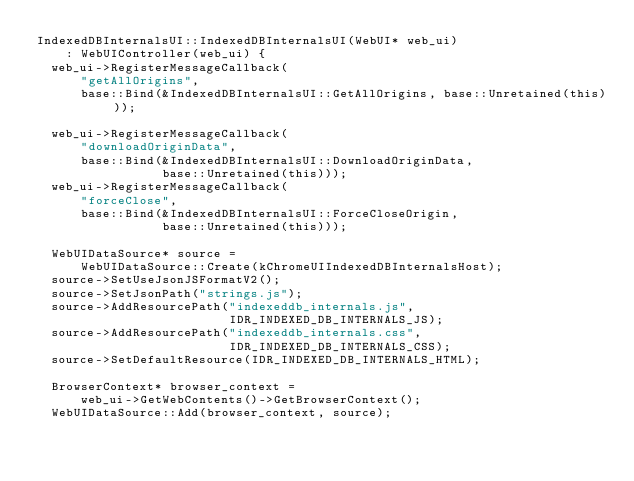Convert code to text. <code><loc_0><loc_0><loc_500><loc_500><_C++_>IndexedDBInternalsUI::IndexedDBInternalsUI(WebUI* web_ui)
    : WebUIController(web_ui) {
  web_ui->RegisterMessageCallback(
      "getAllOrigins",
      base::Bind(&IndexedDBInternalsUI::GetAllOrigins, base::Unretained(this)));

  web_ui->RegisterMessageCallback(
      "downloadOriginData",
      base::Bind(&IndexedDBInternalsUI::DownloadOriginData,
                 base::Unretained(this)));
  web_ui->RegisterMessageCallback(
      "forceClose",
      base::Bind(&IndexedDBInternalsUI::ForceCloseOrigin,
                 base::Unretained(this)));

  WebUIDataSource* source =
      WebUIDataSource::Create(kChromeUIIndexedDBInternalsHost);
  source->SetUseJsonJSFormatV2();
  source->SetJsonPath("strings.js");
  source->AddResourcePath("indexeddb_internals.js",
                          IDR_INDEXED_DB_INTERNALS_JS);
  source->AddResourcePath("indexeddb_internals.css",
                          IDR_INDEXED_DB_INTERNALS_CSS);
  source->SetDefaultResource(IDR_INDEXED_DB_INTERNALS_HTML);

  BrowserContext* browser_context =
      web_ui->GetWebContents()->GetBrowserContext();
  WebUIDataSource::Add(browser_context, source);</code> 